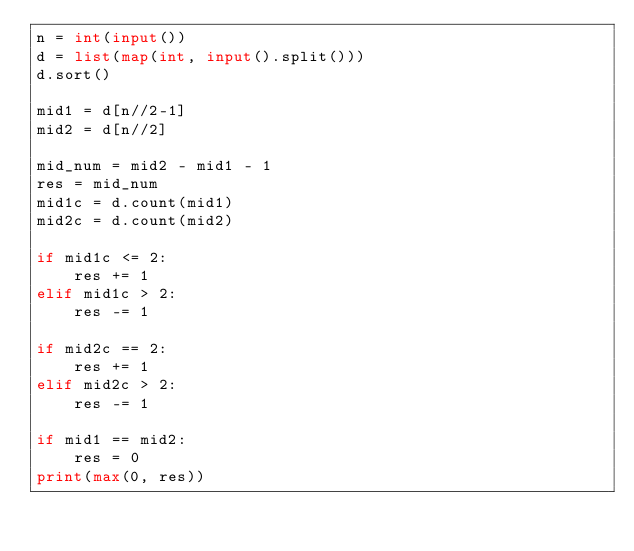<code> <loc_0><loc_0><loc_500><loc_500><_Python_>n = int(input())
d = list(map(int, input().split()))
d.sort()

mid1 = d[n//2-1]
mid2 = d[n//2]

mid_num = mid2 - mid1 - 1
res = mid_num
mid1c = d.count(mid1)
mid2c = d.count(mid2)

if mid1c <= 2:
    res += 1
elif mid1c > 2:
    res -= 1

if mid2c == 2:
    res += 1
elif mid2c > 2:
    res -= 1

if mid1 == mid2:
    res = 0
print(max(0, res))
</code> 